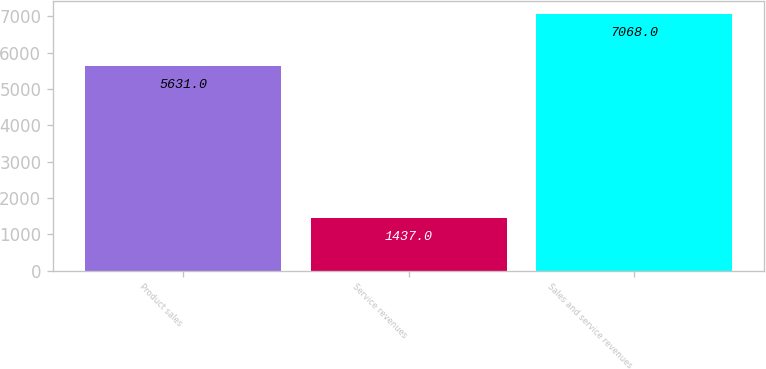Convert chart to OTSL. <chart><loc_0><loc_0><loc_500><loc_500><bar_chart><fcel>Product sales<fcel>Service revenues<fcel>Sales and service revenues<nl><fcel>5631<fcel>1437<fcel>7068<nl></chart> 